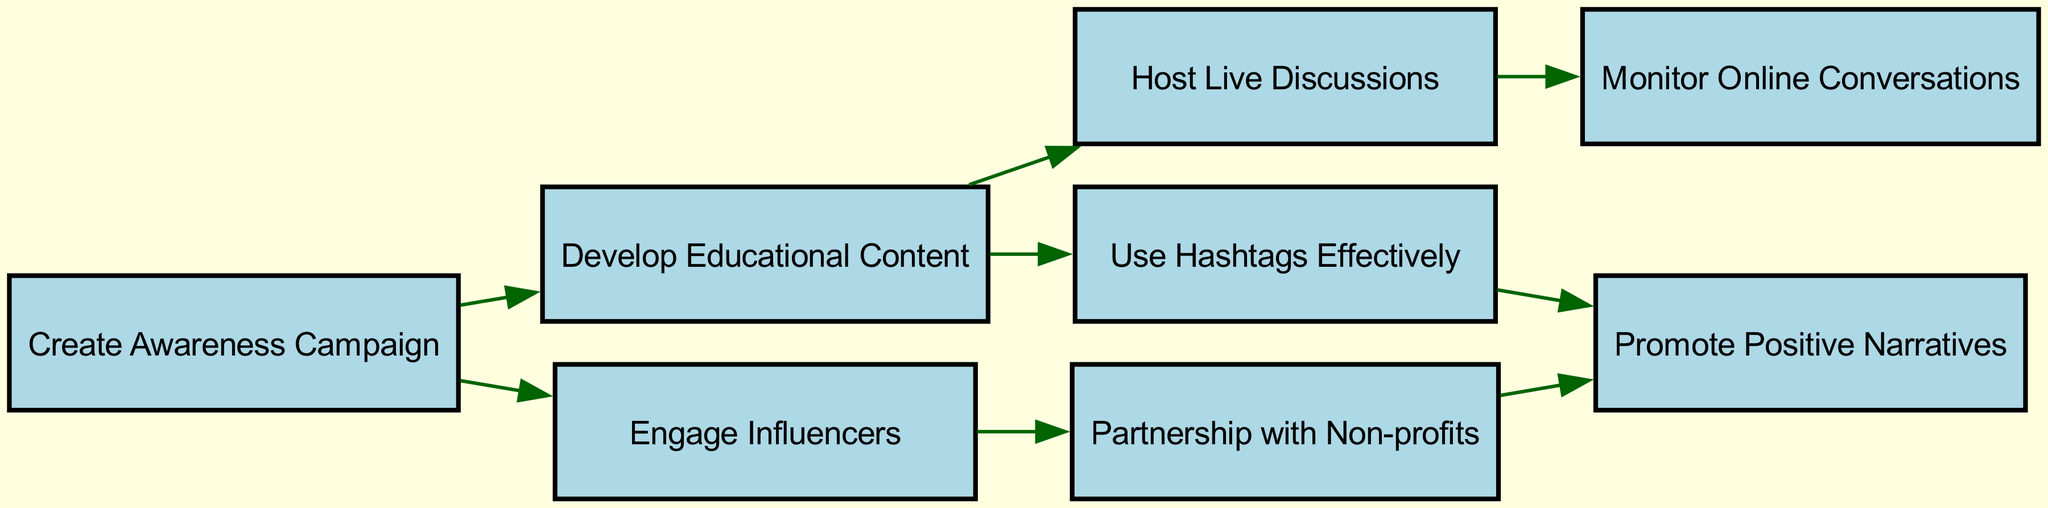What is the total number of nodes in the diagram? The diagram lists nodes representing different strategies for the campaign, and counting each node gives a total of eight distinct strategies or concepts involved.
Answer: eight What are the two nodes directly connected to "Create Awareness Campaign"? "Create Awareness Campaign" has edges connecting to "Develop Educational Content" and "Engage Influencers". These are the two nodes that it directly influences.
Answer: Develop Educational Content, Engage Influencers Which node has the most outgoing edges? Analyzing the diagram, "Develop Educational Content" has two outgoing edges leading to "Use Hashtags Effectively" and "Host Live Discussions", which makes it the node with the most outgoing connections.
Answer: Develop Educational Content Which strategies lead to promoting positive narratives? The node "Promote Positive Narratives" is reached through "Partnership with Non-profits" and "Use Hashtags Effectively", as both of these nodes have edges leading to it.
Answer: Partnership with Non-profits, Use Hashtags Effectively How many edges are present in the diagram? By counting the connections (or edges) shown in the diagram, there are a total of seven distinct edges connecting the various nodes.
Answer: seven What is the relationship between "Host Live Discussions" and "Monitor Online Conversations"? "Host Live Discussions" leads to "Monitor Online Conversations", meaning that hosting discussions will result in monitoring what is being said online, establishing a direct influence path from discussions to monitoring.
Answer: Host Live Discussions → Monitor Online Conversations Which two nodes are involved in the initial stages of the campaign strategy? The initial stages indicated in the diagram start with "Create Awareness Campaign", from which it branches out towards "Develop Educational Content" and "Engage Influencers". These are crucial starting nodes for the campaign strategy.
Answer: Create Awareness Campaign, Develop Educational Content Which node connects to the most strategies from the "Develop Educational Content"? Only "Develop Educational Content" branches out to "Use Hashtags Effectively" and "Host Live Discussions," leading to a diverse range of further strategies. Therefore, it serves as a connector to multiple outcomes in the campaign.
Answer: Use Hashtags Effectively, Host Live Discussions 